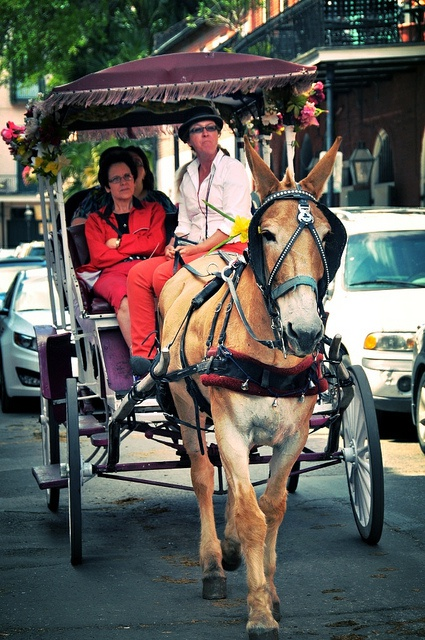Describe the objects in this image and their specific colors. I can see horse in darkgreen, black, gray, and tan tones, car in darkgreen, white, black, blue, and teal tones, people in darkgreen, lightgray, salmon, black, and red tones, people in darkgreen, red, black, brown, and maroon tones, and car in darkgreen, white, teal, and black tones in this image. 